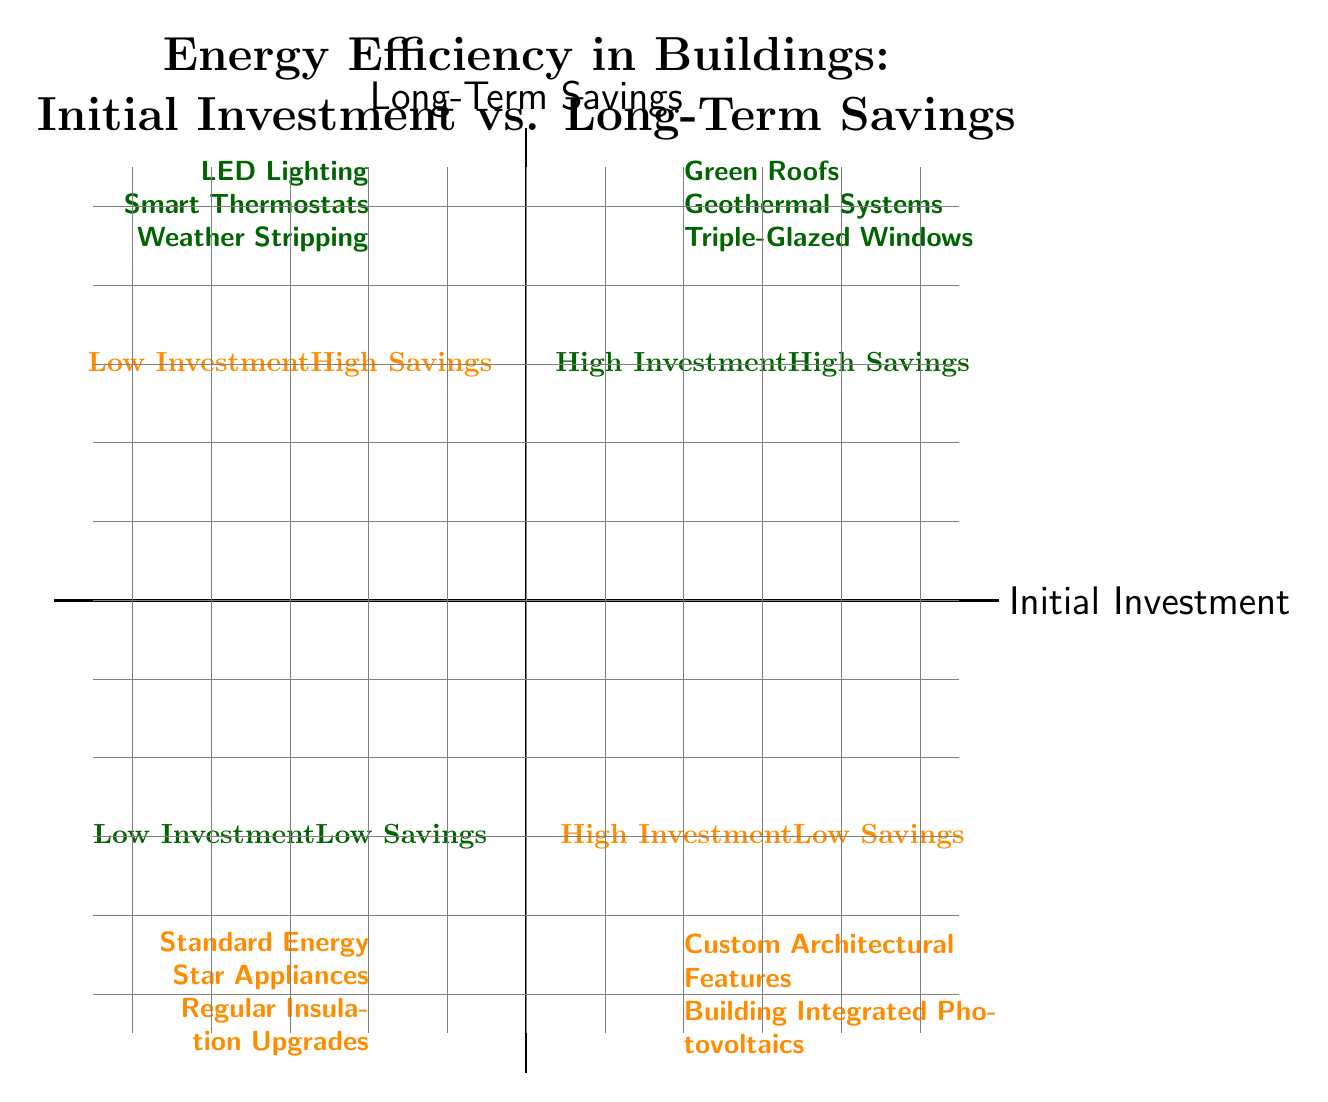What types of technologies are in the quadrant for High Initial Investment - High Long-Term Savings? The quadrant labeled "High Investment - High Savings" includes three technologies: Green Roofs, Geothermal Heating and Cooling Systems, and Triple-Glazed Windows.
Answer: Green Roofs, Geothermal Heating and Cooling Systems, Triple-Glazed Windows How many technologies exhibit a Low Initial Investment - High Long-Term Savings? The "Low Investment - High Savings" quadrant lists three technologies: LED Lighting, Smart Thermostats, and Weather Stripping. Therefore, the count is three.
Answer: 3 Which quadrant features Custom Architectural Features? Custom Architectural Features are located in the quadrant labeled "High Investment - Low Savings." This quadrant is positioned in the lower-right area of the diagram.
Answer: High Investment - Low Savings What do all technologies in the Low Initial Investment - Low Long-Term Savings quadrant have in common? Technologies in this quadrant, Standard Energy Star Appliances and Regular Insulation Upgrades, both have relatively low upfront costs and produce only marginal long-term energy savings. Thus, they share this characteristic.
Answer: Low costs, marginal savings Which technology in the High Initial Investment - Low Long-Term Savings quadrant has moderate energy savings? Building Integrated Photovoltaics (BIPV) falls under the "High Investment - Low Savings" quadrant and is characterized by high initial costs combined with moderate energy savings due to variable solar energy production.
Answer: Building Integrated Photovoltaics Why would one choose Geothermal Heating and Cooling Systems despite the high initial investment? The significant long-term energy savings and reduced utility bills from Geothermal Heating and Cooling Systems justify the initial investment, making them an attractive option despite the upfront costs.
Answer: Long-term savings, reduced bills What is the distinguishing feature of technologies in the Low Investment - High Savings quadrant? Technologies like LED Lighting, Smart Thermostats, and Weather Stripping, which belong to the "Low Investment - High Savings" quadrant, are distinguished by their affordable upfront costs while providing significant energy savings over time.
Answer: Affordable, significant savings How do High Initial Investment technologies compare with the Low Initial Investment technologies in terms of long-term savings? High Initial Investment technologies (like Green Roofs and Geothermal Systems) typically yield substantial long-term savings, while Low Initial Investment technologies (like Standard Energy Star Appliances) produce only modest savings. This contrast highlights a key differentiation in energy performance.
Answer: High savings vs. modest savings 